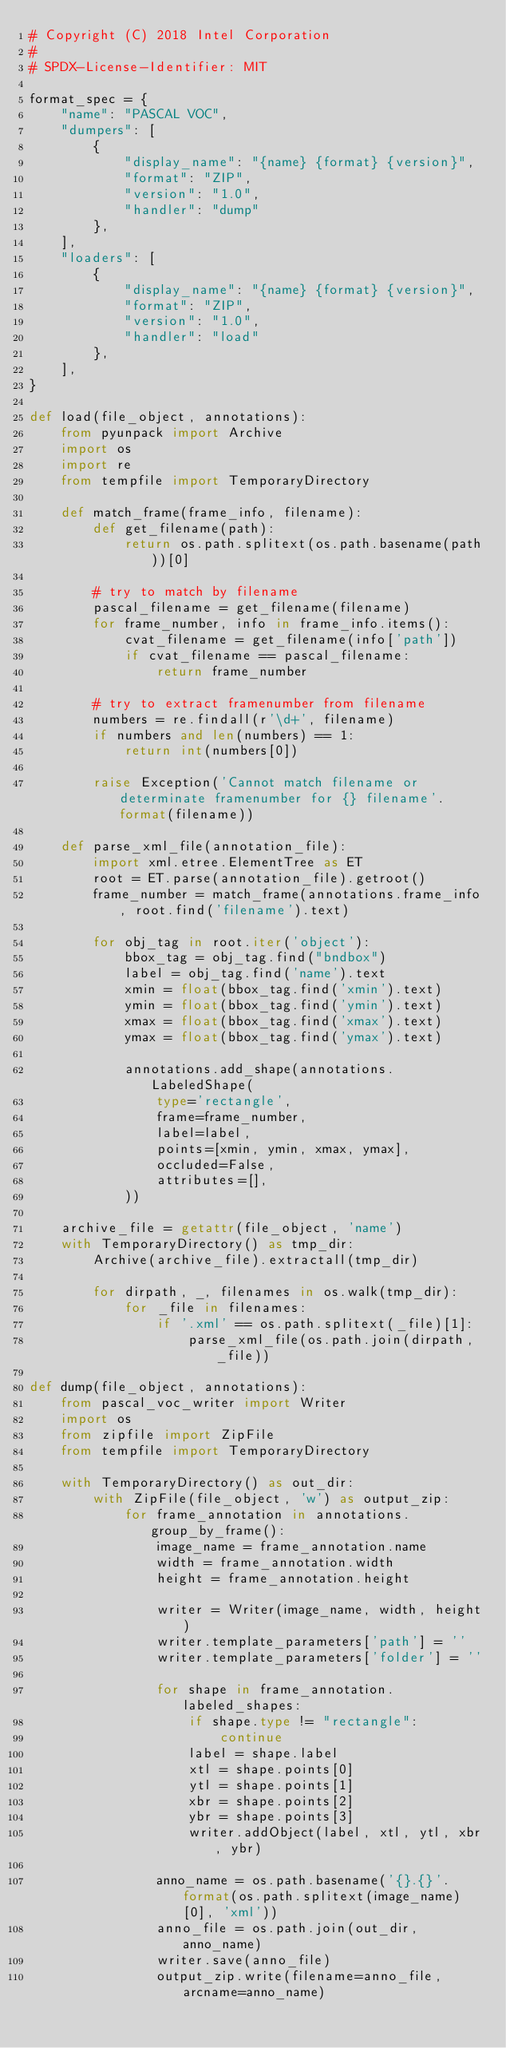Convert code to text. <code><loc_0><loc_0><loc_500><loc_500><_Python_># Copyright (C) 2018 Intel Corporation
#
# SPDX-License-Identifier: MIT

format_spec = {
    "name": "PASCAL VOC",
    "dumpers": [
        {
            "display_name": "{name} {format} {version}",
            "format": "ZIP",
            "version": "1.0",
            "handler": "dump"
        },
    ],
    "loaders": [
        {
            "display_name": "{name} {format} {version}",
            "format": "ZIP",
            "version": "1.0",
            "handler": "load"
        },
    ],
}

def load(file_object, annotations):
    from pyunpack import Archive
    import os
    import re
    from tempfile import TemporaryDirectory

    def match_frame(frame_info, filename):
        def get_filename(path):
            return os.path.splitext(os.path.basename(path))[0]

        # try to match by filename
        pascal_filename = get_filename(filename)
        for frame_number, info in frame_info.items():
            cvat_filename = get_filename(info['path'])
            if cvat_filename == pascal_filename:
                return frame_number

        # try to extract framenumber from filename
        numbers = re.findall(r'\d+', filename)
        if numbers and len(numbers) == 1:
            return int(numbers[0])

        raise Exception('Cannot match filename or determinate framenumber for {} filename'.format(filename))

    def parse_xml_file(annotation_file):
        import xml.etree.ElementTree as ET
        root = ET.parse(annotation_file).getroot()
        frame_number = match_frame(annotations.frame_info, root.find('filename').text)

        for obj_tag in root.iter('object'):
            bbox_tag = obj_tag.find("bndbox")
            label = obj_tag.find('name').text
            xmin = float(bbox_tag.find('xmin').text)
            ymin = float(bbox_tag.find('ymin').text)
            xmax = float(bbox_tag.find('xmax').text)
            ymax = float(bbox_tag.find('ymax').text)

            annotations.add_shape(annotations.LabeledShape(
                type='rectangle',
                frame=frame_number,
                label=label,
                points=[xmin, ymin, xmax, ymax],
                occluded=False,
                attributes=[],
            ))

    archive_file = getattr(file_object, 'name')
    with TemporaryDirectory() as tmp_dir:
        Archive(archive_file).extractall(tmp_dir)

        for dirpath, _, filenames in os.walk(tmp_dir):
            for _file in filenames:
                if '.xml' == os.path.splitext(_file)[1]:
                    parse_xml_file(os.path.join(dirpath, _file))

def dump(file_object, annotations):
    from pascal_voc_writer import Writer
    import os
    from zipfile import ZipFile
    from tempfile import TemporaryDirectory

    with TemporaryDirectory() as out_dir:
        with ZipFile(file_object, 'w') as output_zip:
            for frame_annotation in annotations.group_by_frame():
                image_name = frame_annotation.name
                width = frame_annotation.width
                height = frame_annotation.height

                writer = Writer(image_name, width, height)
                writer.template_parameters['path'] = ''
                writer.template_parameters['folder'] = ''

                for shape in frame_annotation.labeled_shapes:
                    if shape.type != "rectangle":
                        continue
                    label = shape.label
                    xtl = shape.points[0]
                    ytl = shape.points[1]
                    xbr = shape.points[2]
                    ybr = shape.points[3]
                    writer.addObject(label, xtl, ytl, xbr, ybr)

                anno_name = os.path.basename('{}.{}'.format(os.path.splitext(image_name)[0], 'xml'))
                anno_file = os.path.join(out_dir, anno_name)
                writer.save(anno_file)
                output_zip.write(filename=anno_file, arcname=anno_name)
</code> 